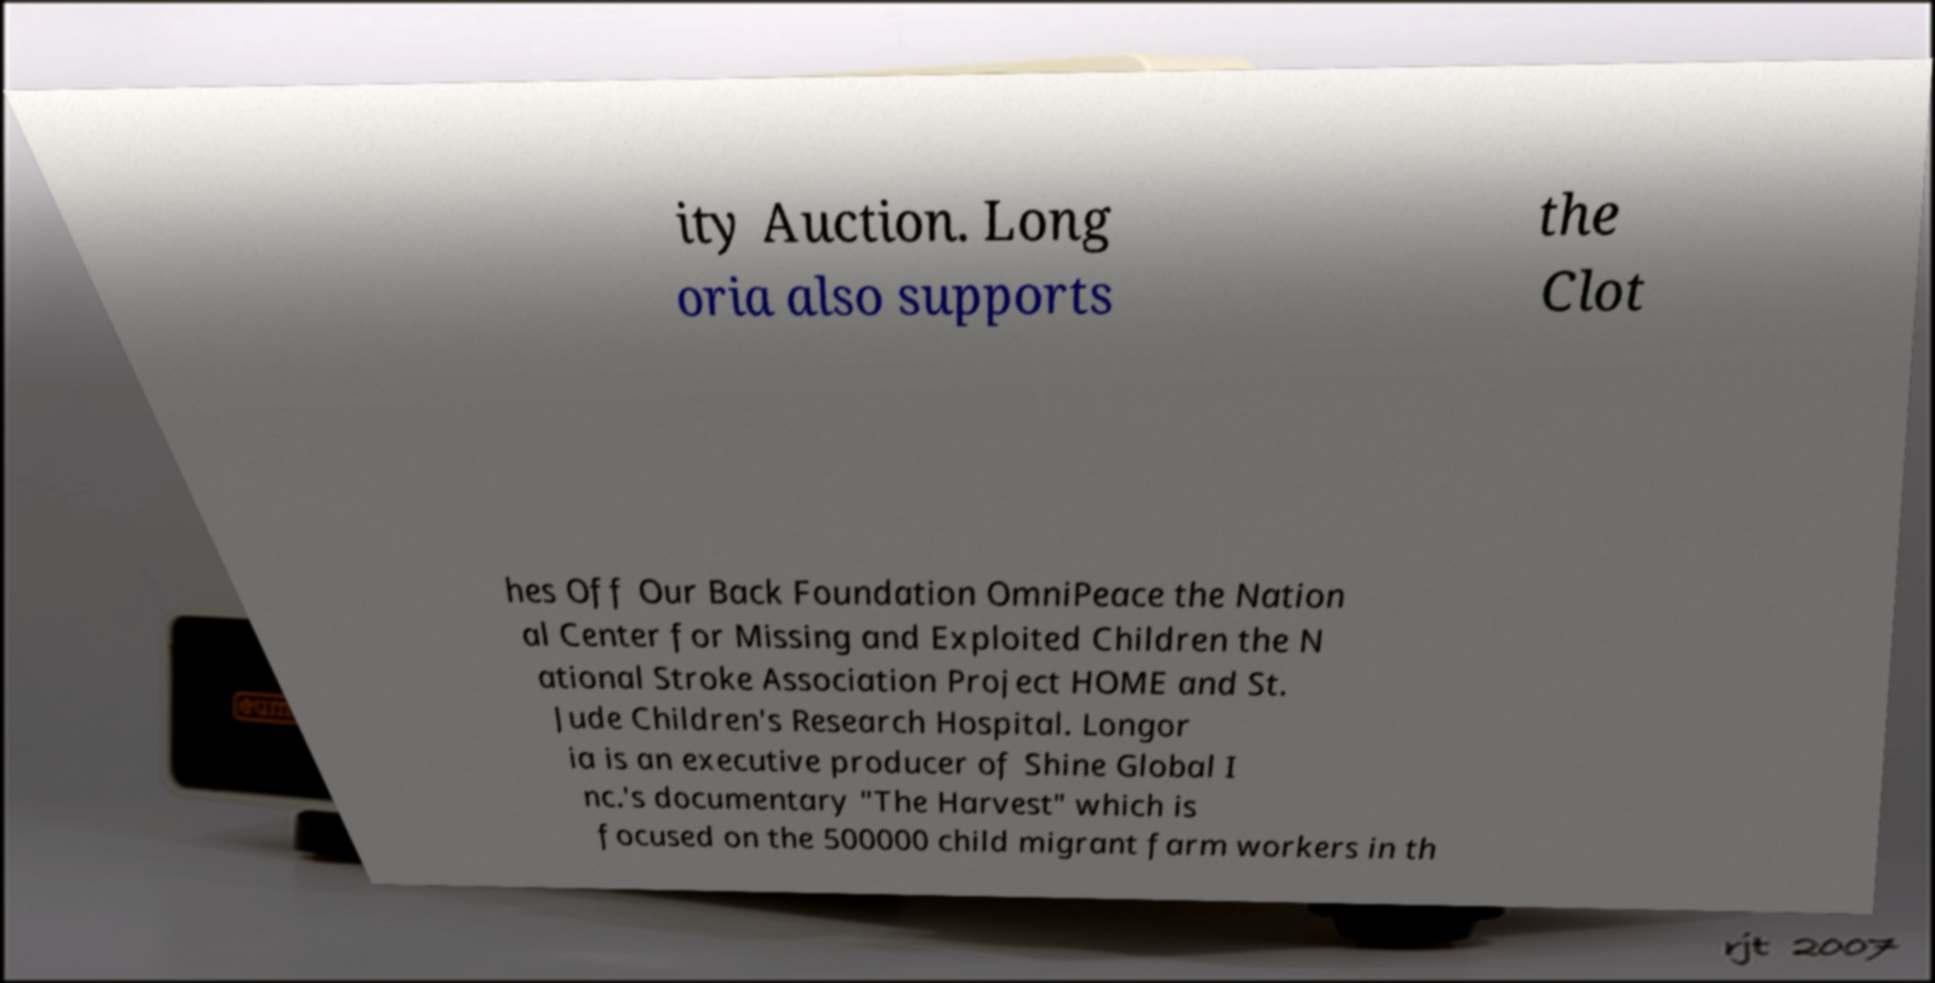Could you extract and type out the text from this image? ity Auction. Long oria also supports the Clot hes Off Our Back Foundation OmniPeace the Nation al Center for Missing and Exploited Children the N ational Stroke Association Project HOME and St. Jude Children's Research Hospital. Longor ia is an executive producer of Shine Global I nc.'s documentary "The Harvest" which is focused on the 500000 child migrant farm workers in th 